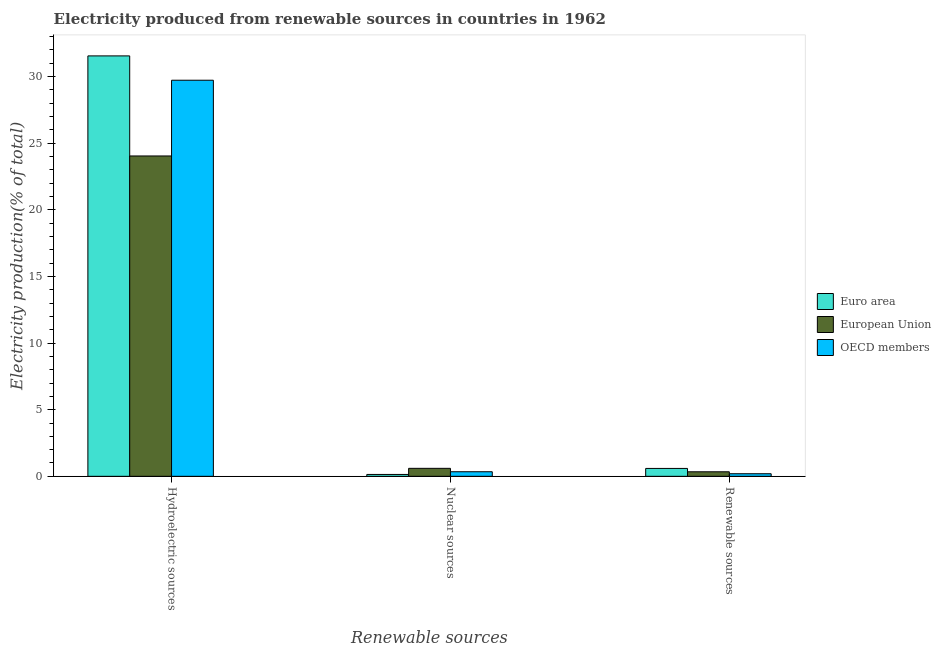How many different coloured bars are there?
Keep it short and to the point. 3. Are the number of bars per tick equal to the number of legend labels?
Provide a short and direct response. Yes. How many bars are there on the 1st tick from the right?
Provide a succinct answer. 3. What is the label of the 1st group of bars from the left?
Your response must be concise. Hydroelectric sources. What is the percentage of electricity produced by hydroelectric sources in OECD members?
Your response must be concise. 29.72. Across all countries, what is the maximum percentage of electricity produced by renewable sources?
Offer a very short reply. 0.59. Across all countries, what is the minimum percentage of electricity produced by nuclear sources?
Provide a succinct answer. 0.14. In which country was the percentage of electricity produced by renewable sources maximum?
Give a very brief answer. Euro area. What is the total percentage of electricity produced by renewable sources in the graph?
Keep it short and to the point. 1.12. What is the difference between the percentage of electricity produced by nuclear sources in Euro area and that in European Union?
Offer a terse response. -0.46. What is the difference between the percentage of electricity produced by hydroelectric sources in Euro area and the percentage of electricity produced by nuclear sources in European Union?
Give a very brief answer. 30.94. What is the average percentage of electricity produced by renewable sources per country?
Keep it short and to the point. 0.37. What is the difference between the percentage of electricity produced by hydroelectric sources and percentage of electricity produced by nuclear sources in OECD members?
Ensure brevity in your answer.  29.37. In how many countries, is the percentage of electricity produced by nuclear sources greater than 5 %?
Offer a very short reply. 0. What is the ratio of the percentage of electricity produced by hydroelectric sources in European Union to that in OECD members?
Provide a short and direct response. 0.81. Is the percentage of electricity produced by hydroelectric sources in Euro area less than that in OECD members?
Give a very brief answer. No. What is the difference between the highest and the second highest percentage of electricity produced by renewable sources?
Offer a terse response. 0.25. What is the difference between the highest and the lowest percentage of electricity produced by renewable sources?
Ensure brevity in your answer.  0.4. In how many countries, is the percentage of electricity produced by renewable sources greater than the average percentage of electricity produced by renewable sources taken over all countries?
Make the answer very short. 1. Is the sum of the percentage of electricity produced by nuclear sources in OECD members and European Union greater than the maximum percentage of electricity produced by hydroelectric sources across all countries?
Ensure brevity in your answer.  No. Is it the case that in every country, the sum of the percentage of electricity produced by hydroelectric sources and percentage of electricity produced by nuclear sources is greater than the percentage of electricity produced by renewable sources?
Make the answer very short. Yes. How many countries are there in the graph?
Your answer should be compact. 3. What is the difference between two consecutive major ticks on the Y-axis?
Keep it short and to the point. 5. Where does the legend appear in the graph?
Give a very brief answer. Center right. How many legend labels are there?
Your answer should be very brief. 3. What is the title of the graph?
Make the answer very short. Electricity produced from renewable sources in countries in 1962. Does "Curacao" appear as one of the legend labels in the graph?
Your answer should be compact. No. What is the label or title of the X-axis?
Provide a succinct answer. Renewable sources. What is the label or title of the Y-axis?
Give a very brief answer. Electricity production(% of total). What is the Electricity production(% of total) in Euro area in Hydroelectric sources?
Your answer should be very brief. 31.54. What is the Electricity production(% of total) of European Union in Hydroelectric sources?
Your answer should be compact. 24.03. What is the Electricity production(% of total) of OECD members in Hydroelectric sources?
Make the answer very short. 29.72. What is the Electricity production(% of total) of Euro area in Nuclear sources?
Offer a terse response. 0.14. What is the Electricity production(% of total) in European Union in Nuclear sources?
Keep it short and to the point. 0.6. What is the Electricity production(% of total) of OECD members in Nuclear sources?
Give a very brief answer. 0.34. What is the Electricity production(% of total) of Euro area in Renewable sources?
Your response must be concise. 0.59. What is the Electricity production(% of total) of European Union in Renewable sources?
Provide a succinct answer. 0.34. What is the Electricity production(% of total) in OECD members in Renewable sources?
Offer a very short reply. 0.19. Across all Renewable sources, what is the maximum Electricity production(% of total) of Euro area?
Offer a very short reply. 31.54. Across all Renewable sources, what is the maximum Electricity production(% of total) of European Union?
Ensure brevity in your answer.  24.03. Across all Renewable sources, what is the maximum Electricity production(% of total) in OECD members?
Offer a terse response. 29.72. Across all Renewable sources, what is the minimum Electricity production(% of total) of Euro area?
Make the answer very short. 0.14. Across all Renewable sources, what is the minimum Electricity production(% of total) in European Union?
Give a very brief answer. 0.34. Across all Renewable sources, what is the minimum Electricity production(% of total) of OECD members?
Your response must be concise. 0.19. What is the total Electricity production(% of total) in Euro area in the graph?
Make the answer very short. 32.27. What is the total Electricity production(% of total) in European Union in the graph?
Offer a very short reply. 24.97. What is the total Electricity production(% of total) in OECD members in the graph?
Your answer should be very brief. 30.25. What is the difference between the Electricity production(% of total) in Euro area in Hydroelectric sources and that in Nuclear sources?
Your response must be concise. 31.4. What is the difference between the Electricity production(% of total) of European Union in Hydroelectric sources and that in Nuclear sources?
Keep it short and to the point. 23.43. What is the difference between the Electricity production(% of total) in OECD members in Hydroelectric sources and that in Nuclear sources?
Offer a very short reply. 29.37. What is the difference between the Electricity production(% of total) in Euro area in Hydroelectric sources and that in Renewable sources?
Provide a succinct answer. 30.95. What is the difference between the Electricity production(% of total) in European Union in Hydroelectric sources and that in Renewable sources?
Your answer should be compact. 23.69. What is the difference between the Electricity production(% of total) of OECD members in Hydroelectric sources and that in Renewable sources?
Your answer should be compact. 29.52. What is the difference between the Electricity production(% of total) of Euro area in Nuclear sources and that in Renewable sources?
Offer a very short reply. -0.45. What is the difference between the Electricity production(% of total) of European Union in Nuclear sources and that in Renewable sources?
Offer a very short reply. 0.26. What is the difference between the Electricity production(% of total) in OECD members in Nuclear sources and that in Renewable sources?
Provide a succinct answer. 0.15. What is the difference between the Electricity production(% of total) of Euro area in Hydroelectric sources and the Electricity production(% of total) of European Union in Nuclear sources?
Your response must be concise. 30.94. What is the difference between the Electricity production(% of total) of Euro area in Hydroelectric sources and the Electricity production(% of total) of OECD members in Nuclear sources?
Ensure brevity in your answer.  31.2. What is the difference between the Electricity production(% of total) in European Union in Hydroelectric sources and the Electricity production(% of total) in OECD members in Nuclear sources?
Offer a very short reply. 23.69. What is the difference between the Electricity production(% of total) of Euro area in Hydroelectric sources and the Electricity production(% of total) of European Union in Renewable sources?
Offer a terse response. 31.2. What is the difference between the Electricity production(% of total) of Euro area in Hydroelectric sources and the Electricity production(% of total) of OECD members in Renewable sources?
Make the answer very short. 31.35. What is the difference between the Electricity production(% of total) in European Union in Hydroelectric sources and the Electricity production(% of total) in OECD members in Renewable sources?
Your answer should be very brief. 23.84. What is the difference between the Electricity production(% of total) of Euro area in Nuclear sources and the Electricity production(% of total) of European Union in Renewable sources?
Keep it short and to the point. -0.2. What is the difference between the Electricity production(% of total) of Euro area in Nuclear sources and the Electricity production(% of total) of OECD members in Renewable sources?
Keep it short and to the point. -0.05. What is the difference between the Electricity production(% of total) of European Union in Nuclear sources and the Electricity production(% of total) of OECD members in Renewable sources?
Provide a short and direct response. 0.41. What is the average Electricity production(% of total) of Euro area per Renewable sources?
Give a very brief answer. 10.76. What is the average Electricity production(% of total) of European Union per Renewable sources?
Your answer should be very brief. 8.32. What is the average Electricity production(% of total) of OECD members per Renewable sources?
Make the answer very short. 10.08. What is the difference between the Electricity production(% of total) in Euro area and Electricity production(% of total) in European Union in Hydroelectric sources?
Give a very brief answer. 7.51. What is the difference between the Electricity production(% of total) in Euro area and Electricity production(% of total) in OECD members in Hydroelectric sources?
Your response must be concise. 1.83. What is the difference between the Electricity production(% of total) in European Union and Electricity production(% of total) in OECD members in Hydroelectric sources?
Ensure brevity in your answer.  -5.68. What is the difference between the Electricity production(% of total) of Euro area and Electricity production(% of total) of European Union in Nuclear sources?
Offer a terse response. -0.46. What is the difference between the Electricity production(% of total) of Euro area and Electricity production(% of total) of OECD members in Nuclear sources?
Offer a very short reply. -0.2. What is the difference between the Electricity production(% of total) in European Union and Electricity production(% of total) in OECD members in Nuclear sources?
Keep it short and to the point. 0.26. What is the difference between the Electricity production(% of total) of Euro area and Electricity production(% of total) of European Union in Renewable sources?
Offer a very short reply. 0.25. What is the difference between the Electricity production(% of total) in Euro area and Electricity production(% of total) in OECD members in Renewable sources?
Offer a very short reply. 0.4. What is the difference between the Electricity production(% of total) in European Union and Electricity production(% of total) in OECD members in Renewable sources?
Your answer should be very brief. 0.15. What is the ratio of the Electricity production(% of total) in Euro area in Hydroelectric sources to that in Nuclear sources?
Offer a very short reply. 223.75. What is the ratio of the Electricity production(% of total) in European Union in Hydroelectric sources to that in Nuclear sources?
Your answer should be compact. 40.13. What is the ratio of the Electricity production(% of total) of OECD members in Hydroelectric sources to that in Nuclear sources?
Your answer should be very brief. 86.7. What is the ratio of the Electricity production(% of total) in Euro area in Hydroelectric sources to that in Renewable sources?
Give a very brief answer. 53.35. What is the ratio of the Electricity production(% of total) of European Union in Hydroelectric sources to that in Renewable sources?
Your answer should be compact. 70.73. What is the ratio of the Electricity production(% of total) in OECD members in Hydroelectric sources to that in Renewable sources?
Keep it short and to the point. 153.58. What is the ratio of the Electricity production(% of total) in Euro area in Nuclear sources to that in Renewable sources?
Your response must be concise. 0.24. What is the ratio of the Electricity production(% of total) of European Union in Nuclear sources to that in Renewable sources?
Give a very brief answer. 1.76. What is the ratio of the Electricity production(% of total) of OECD members in Nuclear sources to that in Renewable sources?
Ensure brevity in your answer.  1.77. What is the difference between the highest and the second highest Electricity production(% of total) in Euro area?
Offer a terse response. 30.95. What is the difference between the highest and the second highest Electricity production(% of total) in European Union?
Make the answer very short. 23.43. What is the difference between the highest and the second highest Electricity production(% of total) of OECD members?
Provide a short and direct response. 29.37. What is the difference between the highest and the lowest Electricity production(% of total) of Euro area?
Provide a succinct answer. 31.4. What is the difference between the highest and the lowest Electricity production(% of total) of European Union?
Ensure brevity in your answer.  23.69. What is the difference between the highest and the lowest Electricity production(% of total) of OECD members?
Keep it short and to the point. 29.52. 